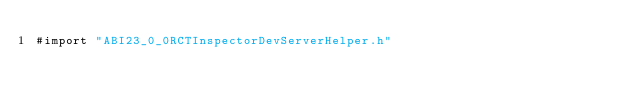Convert code to text. <code><loc_0><loc_0><loc_500><loc_500><_ObjectiveC_>#import "ABI23_0_0RCTInspectorDevServerHelper.h"
</code> 